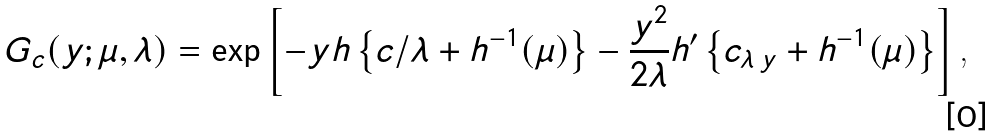<formula> <loc_0><loc_0><loc_500><loc_500>G _ { c } ( y ; \mu , \lambda ) = \exp \left [ - y h \left \{ c / \lambda + h ^ { - 1 } ( \mu ) \right \} - \frac { y ^ { 2 } } { 2 \lambda } h ^ { \prime } \left \{ c _ { \lambda \, y } + h ^ { - 1 } ( \mu ) \right \} \right ] \text {,}</formula> 